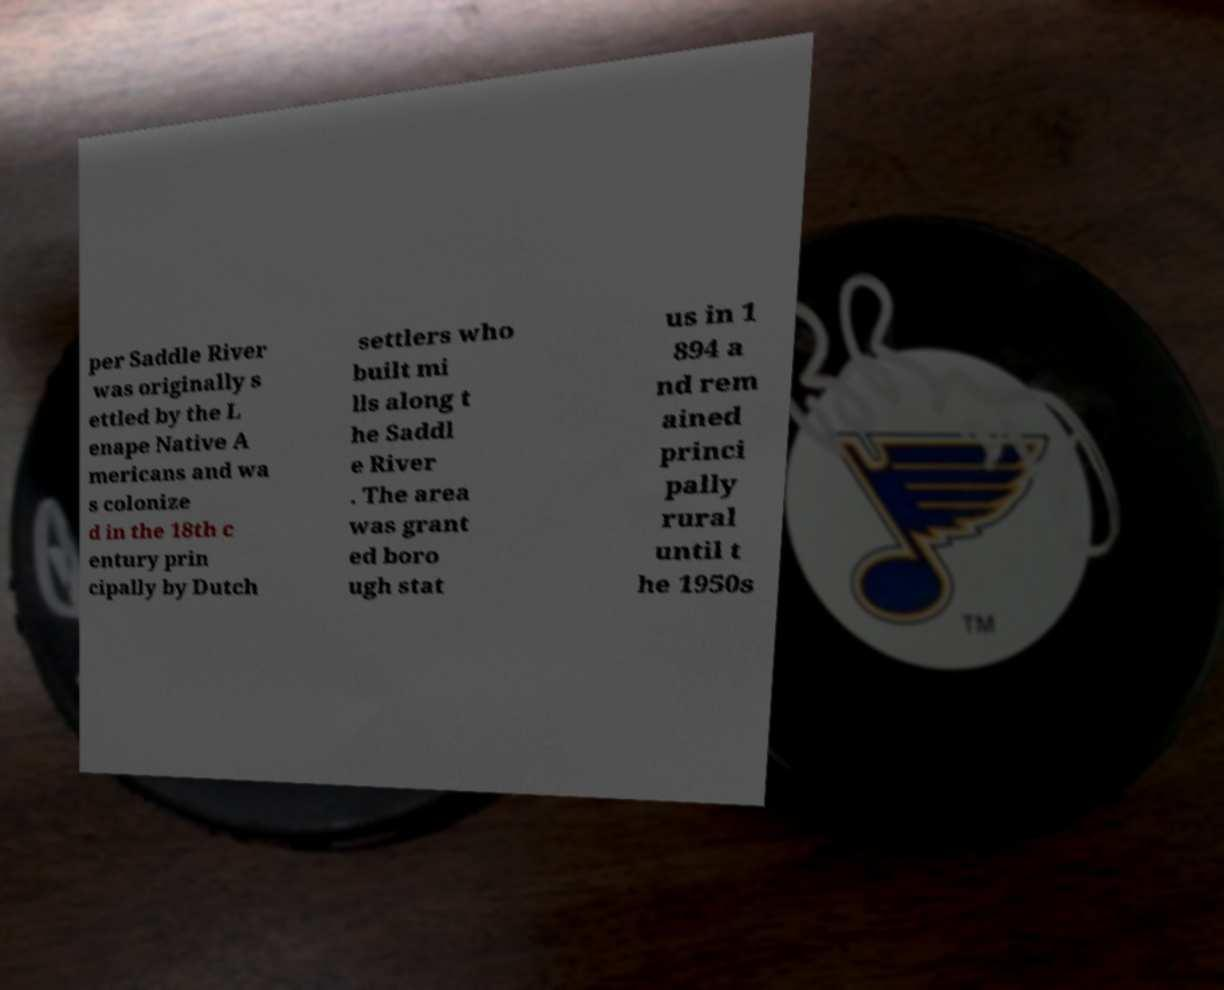I need the written content from this picture converted into text. Can you do that? per Saddle River was originally s ettled by the L enape Native A mericans and wa s colonize d in the 18th c entury prin cipally by Dutch settlers who built mi lls along t he Saddl e River . The area was grant ed boro ugh stat us in 1 894 a nd rem ained princi pally rural until t he 1950s 